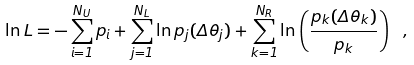Convert formula to latex. <formula><loc_0><loc_0><loc_500><loc_500>\ln L = - \sum _ { i = 1 } ^ { N _ { U } } p _ { i } + \sum _ { j = 1 } ^ { N _ { L } } \ln p _ { j } ( \Delta \theta _ { j } ) + \sum _ { k = 1 } ^ { N _ { R } } \ln \left ( \frac { p _ { k } ( \Delta \theta _ { k } ) } { p _ { k } } \right ) \ ,</formula> 